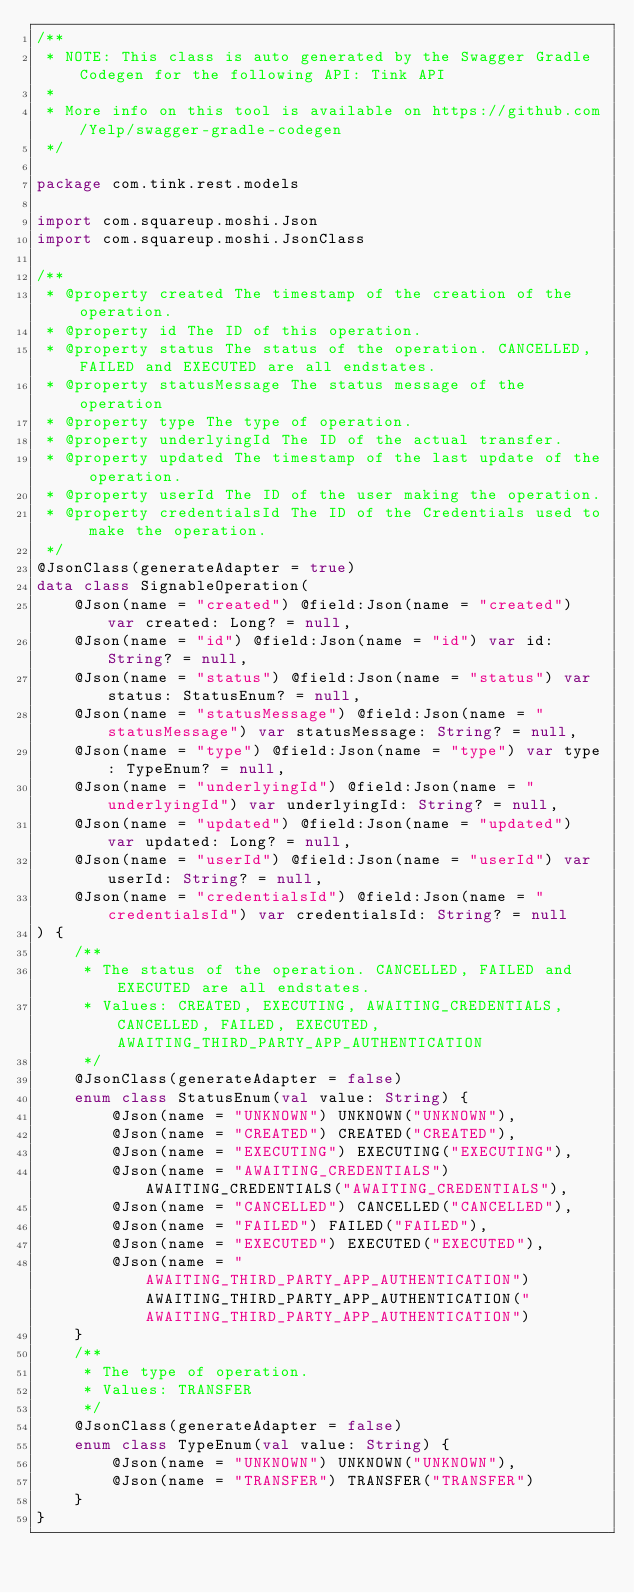<code> <loc_0><loc_0><loc_500><loc_500><_Kotlin_>/**
 * NOTE: This class is auto generated by the Swagger Gradle Codegen for the following API: Tink API
 *
 * More info on this tool is available on https://github.com/Yelp/swagger-gradle-codegen
 */

package com.tink.rest.models

import com.squareup.moshi.Json
import com.squareup.moshi.JsonClass

/**
 * @property created The timestamp of the creation of the operation.
 * @property id The ID of this operation.
 * @property status The status of the operation. CANCELLED, FAILED and EXECUTED are all endstates.
 * @property statusMessage The status message of the operation
 * @property type The type of operation.
 * @property underlyingId The ID of the actual transfer.
 * @property updated The timestamp of the last update of the operation.
 * @property userId The ID of the user making the operation.
 * @property credentialsId The ID of the Credentials used to make the operation.
 */
@JsonClass(generateAdapter = true)
data class SignableOperation(
    @Json(name = "created") @field:Json(name = "created") var created: Long? = null,
    @Json(name = "id") @field:Json(name = "id") var id: String? = null,
    @Json(name = "status") @field:Json(name = "status") var status: StatusEnum? = null,
    @Json(name = "statusMessage") @field:Json(name = "statusMessage") var statusMessage: String? = null,
    @Json(name = "type") @field:Json(name = "type") var type: TypeEnum? = null,
    @Json(name = "underlyingId") @field:Json(name = "underlyingId") var underlyingId: String? = null,
    @Json(name = "updated") @field:Json(name = "updated") var updated: Long? = null,
    @Json(name = "userId") @field:Json(name = "userId") var userId: String? = null,
    @Json(name = "credentialsId") @field:Json(name = "credentialsId") var credentialsId: String? = null
) {
    /**
     * The status of the operation. CANCELLED, FAILED and EXECUTED are all endstates.
     * Values: CREATED, EXECUTING, AWAITING_CREDENTIALS, CANCELLED, FAILED, EXECUTED, AWAITING_THIRD_PARTY_APP_AUTHENTICATION
     */
    @JsonClass(generateAdapter = false)
    enum class StatusEnum(val value: String) {
        @Json(name = "UNKNOWN") UNKNOWN("UNKNOWN"),
        @Json(name = "CREATED") CREATED("CREATED"),
        @Json(name = "EXECUTING") EXECUTING("EXECUTING"),
        @Json(name = "AWAITING_CREDENTIALS") AWAITING_CREDENTIALS("AWAITING_CREDENTIALS"),
        @Json(name = "CANCELLED") CANCELLED("CANCELLED"),
        @Json(name = "FAILED") FAILED("FAILED"),
        @Json(name = "EXECUTED") EXECUTED("EXECUTED"),
        @Json(name = "AWAITING_THIRD_PARTY_APP_AUTHENTICATION") AWAITING_THIRD_PARTY_APP_AUTHENTICATION("AWAITING_THIRD_PARTY_APP_AUTHENTICATION")
    }
    /**
     * The type of operation.
     * Values: TRANSFER
     */
    @JsonClass(generateAdapter = false)
    enum class TypeEnum(val value: String) {
        @Json(name = "UNKNOWN") UNKNOWN("UNKNOWN"),
        @Json(name = "TRANSFER") TRANSFER("TRANSFER")
    }
}
</code> 